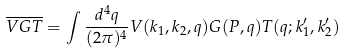Convert formula to latex. <formula><loc_0><loc_0><loc_500><loc_500>\overline { V G T } = \int \frac { d ^ { 4 } q } { ( 2 \pi ) ^ { 4 } } V ( k _ { 1 } , k _ { 2 } , q ) G ( P , q ) T ( q ; k ^ { \prime } _ { 1 } , k ^ { \prime } _ { 2 } )</formula> 